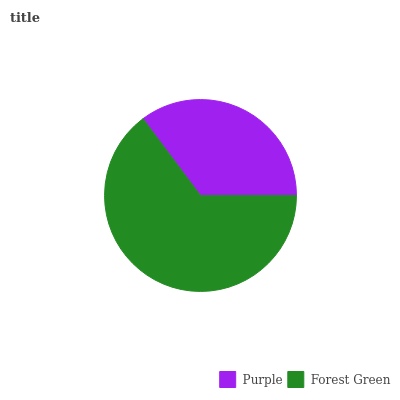Is Purple the minimum?
Answer yes or no. Yes. Is Forest Green the maximum?
Answer yes or no. Yes. Is Forest Green the minimum?
Answer yes or no. No. Is Forest Green greater than Purple?
Answer yes or no. Yes. Is Purple less than Forest Green?
Answer yes or no. Yes. Is Purple greater than Forest Green?
Answer yes or no. No. Is Forest Green less than Purple?
Answer yes or no. No. Is Forest Green the high median?
Answer yes or no. Yes. Is Purple the low median?
Answer yes or no. Yes. Is Purple the high median?
Answer yes or no. No. Is Forest Green the low median?
Answer yes or no. No. 